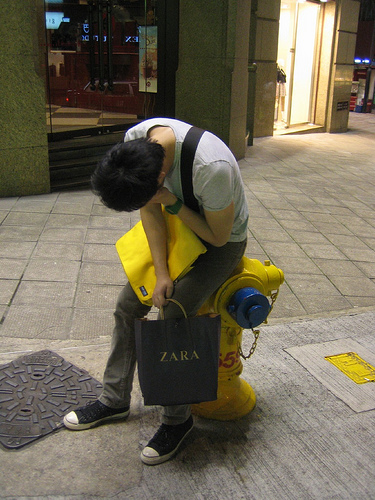Please transcribe the text in this image. ZARA 5 0 